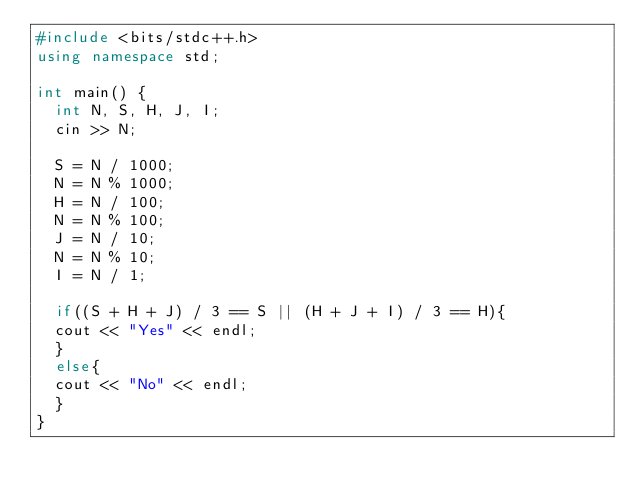Convert code to text. <code><loc_0><loc_0><loc_500><loc_500><_C++_>#include <bits/stdc++.h>
using namespace std;

int main() {
  int N, S, H, J, I;
  cin >> N;

  S = N / 1000;
  N = N % 1000;
  H = N / 100;
  N = N % 100;
  J = N / 10;
  N = N % 10;
  I = N / 1;

  if((S + H + J) / 3 == S || (H + J + I) / 3 == H){
  cout << "Yes" << endl;
  }
  else{
  cout << "No" << endl;
  }
}
</code> 